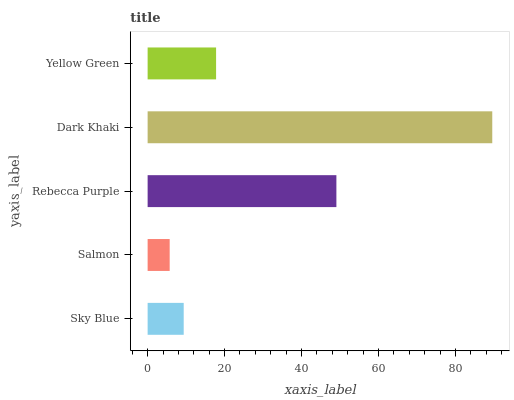Is Salmon the minimum?
Answer yes or no. Yes. Is Dark Khaki the maximum?
Answer yes or no. Yes. Is Rebecca Purple the minimum?
Answer yes or no. No. Is Rebecca Purple the maximum?
Answer yes or no. No. Is Rebecca Purple greater than Salmon?
Answer yes or no. Yes. Is Salmon less than Rebecca Purple?
Answer yes or no. Yes. Is Salmon greater than Rebecca Purple?
Answer yes or no. No. Is Rebecca Purple less than Salmon?
Answer yes or no. No. Is Yellow Green the high median?
Answer yes or no. Yes. Is Yellow Green the low median?
Answer yes or no. Yes. Is Sky Blue the high median?
Answer yes or no. No. Is Sky Blue the low median?
Answer yes or no. No. 